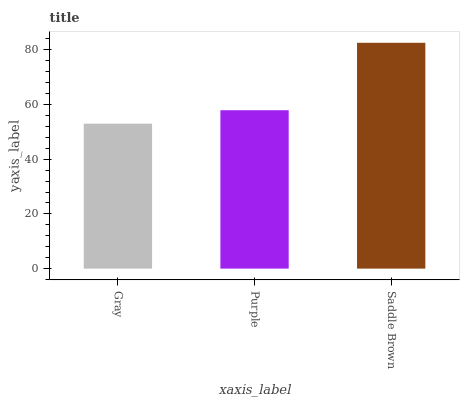Is Gray the minimum?
Answer yes or no. Yes. Is Saddle Brown the maximum?
Answer yes or no. Yes. Is Purple the minimum?
Answer yes or no. No. Is Purple the maximum?
Answer yes or no. No. Is Purple greater than Gray?
Answer yes or no. Yes. Is Gray less than Purple?
Answer yes or no. Yes. Is Gray greater than Purple?
Answer yes or no. No. Is Purple less than Gray?
Answer yes or no. No. Is Purple the high median?
Answer yes or no. Yes. Is Purple the low median?
Answer yes or no. Yes. Is Saddle Brown the high median?
Answer yes or no. No. Is Gray the low median?
Answer yes or no. No. 